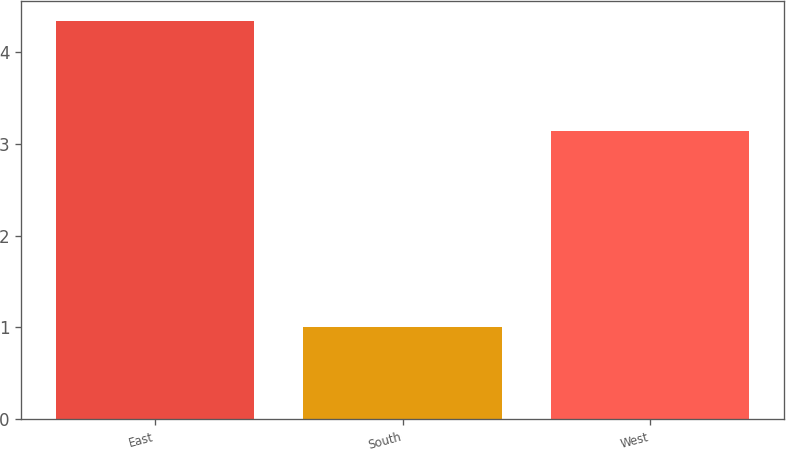Convert chart to OTSL. <chart><loc_0><loc_0><loc_500><loc_500><bar_chart><fcel>East<fcel>South<fcel>West<nl><fcel>4.34<fcel>1<fcel>3.14<nl></chart> 